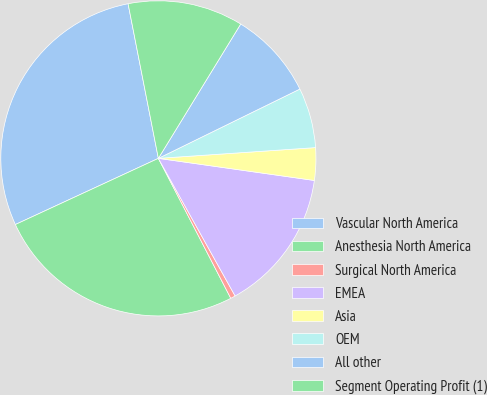Convert chart to OTSL. <chart><loc_0><loc_0><loc_500><loc_500><pie_chart><fcel>Vascular North America<fcel>Anesthesia North America<fcel>Surgical North America<fcel>EMEA<fcel>Asia<fcel>OEM<fcel>All other<fcel>Segment Operating Profit (1)<nl><fcel>28.82%<fcel>25.7%<fcel>0.5%<fcel>14.66%<fcel>3.33%<fcel>6.16%<fcel>9.0%<fcel>11.83%<nl></chart> 